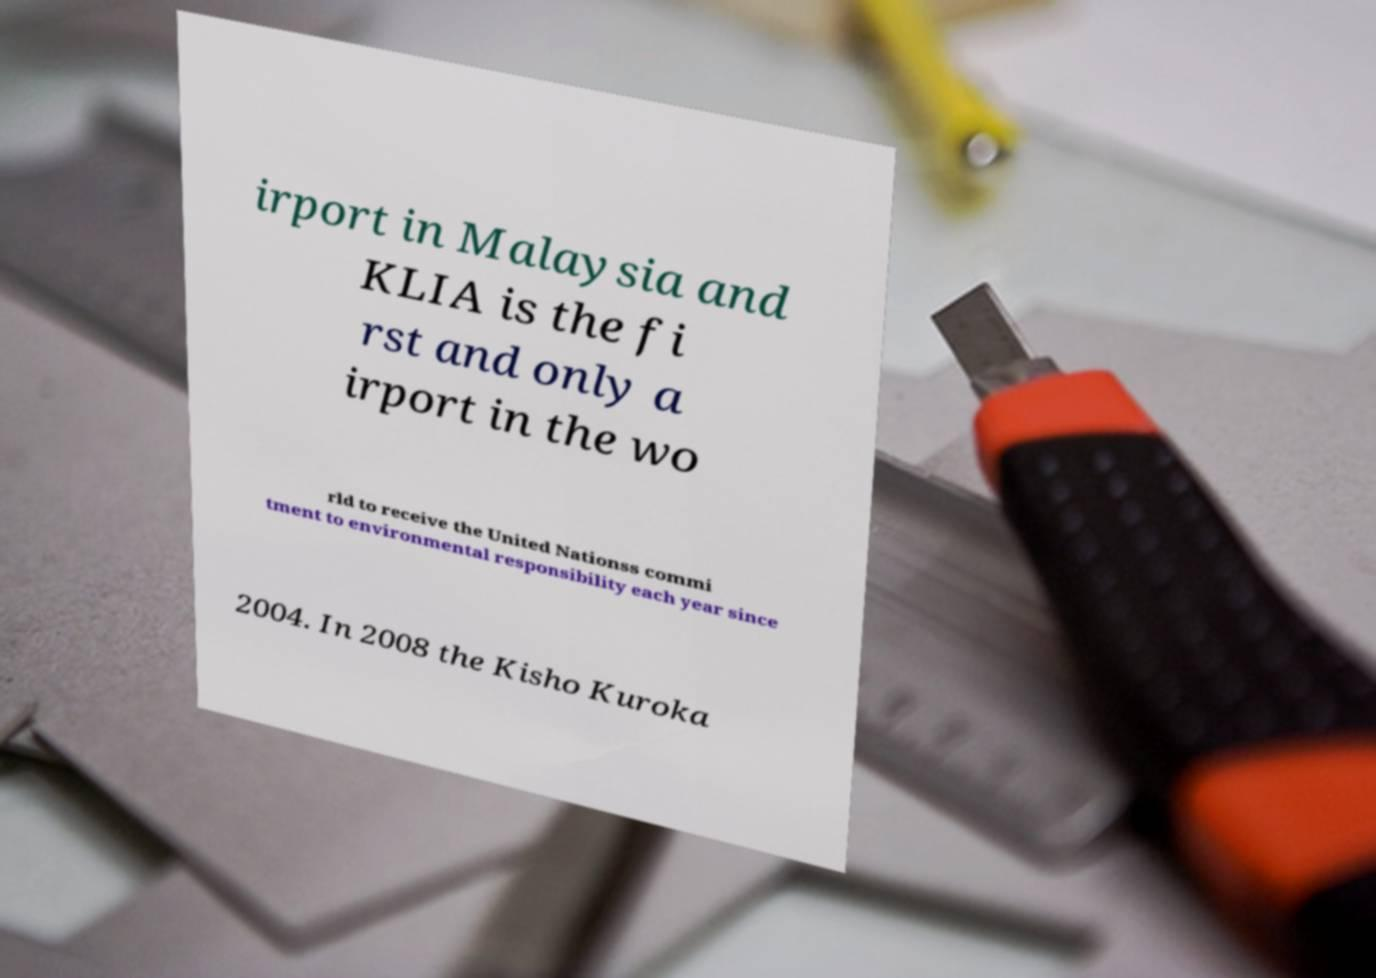Please identify and transcribe the text found in this image. irport in Malaysia and KLIA is the fi rst and only a irport in the wo rld to receive the United Nationss commi tment to environmental responsibility each year since 2004. In 2008 the Kisho Kuroka 